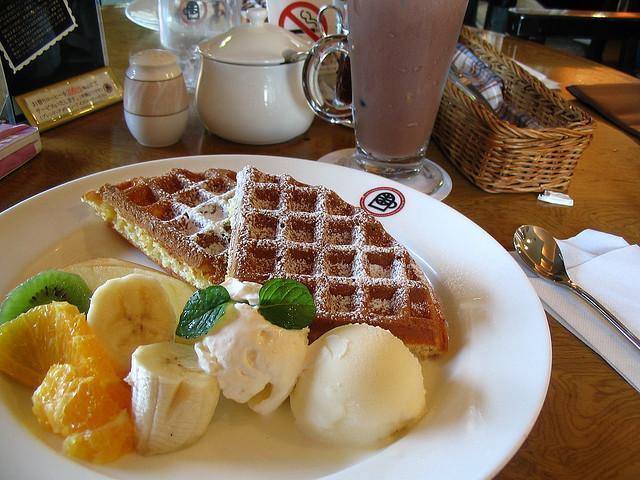How many bananas are in the photo?
Give a very brief answer. 2. 